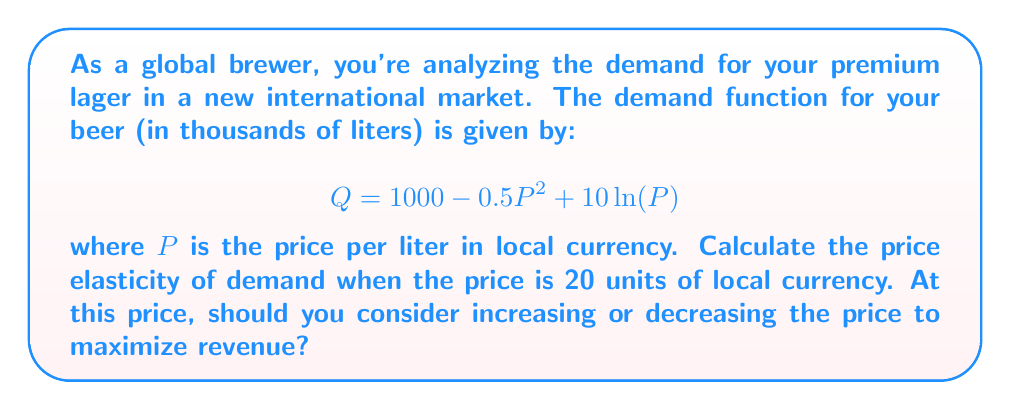Solve this math problem. To solve this problem, we need to follow these steps:

1. Calculate the first derivative of the demand function.
2. Evaluate the derivative at P = 20.
3. Calculate the price elasticity of demand using the formula.
4. Interpret the result to determine pricing strategy.

Step 1: First derivative of the demand function

The demand function is:
$$Q = 1000 - 0.5P^2 + 10\ln(P)$$

Taking the derivative with respect to P:
$$\frac{dQ}{dP} = -P + \frac{10}{P}$$

Step 2: Evaluate the derivative at P = 20

$$\frac{dQ}{dP}\bigg|_{P=20} = -20 + \frac{10}{20} = -20 + 0.5 = -19.5$$

Step 3: Calculate the price elasticity of demand

The formula for price elasticity of demand is:

$$E_d = \frac{dQ}{dP} \cdot \frac{P}{Q}$$

We need to calculate Q when P = 20:

$$Q = 1000 - 0.5(20)^2 + 10\ln(20) = 1000 - 200 + 29.96 = 829.96$$

Now we can calculate the elasticity:

$$E_d = -19.5 \cdot \frac{20}{829.96} = -0.47$$

Step 4: Interpret the result

The price elasticity of demand is -0.47, which is between 0 and -1. This indicates that demand is inelastic at this price point. 

In general:
- If |Ed| > 1, demand is elastic
- If |Ed| < 1, demand is inelastic
- If |Ed| = 1, demand is unit elastic

When demand is inelastic, a price increase will lead to a proportionally smaller decrease in quantity demanded, resulting in higher total revenue. Conversely, a price decrease will lead to a proportionally smaller increase in quantity demanded, resulting in lower total revenue.
Answer: The price elasticity of demand at P = 20 is -0.47. Since the demand is inelastic at this price point (|-0.47| < 1), you should consider increasing the price to maximize revenue. 